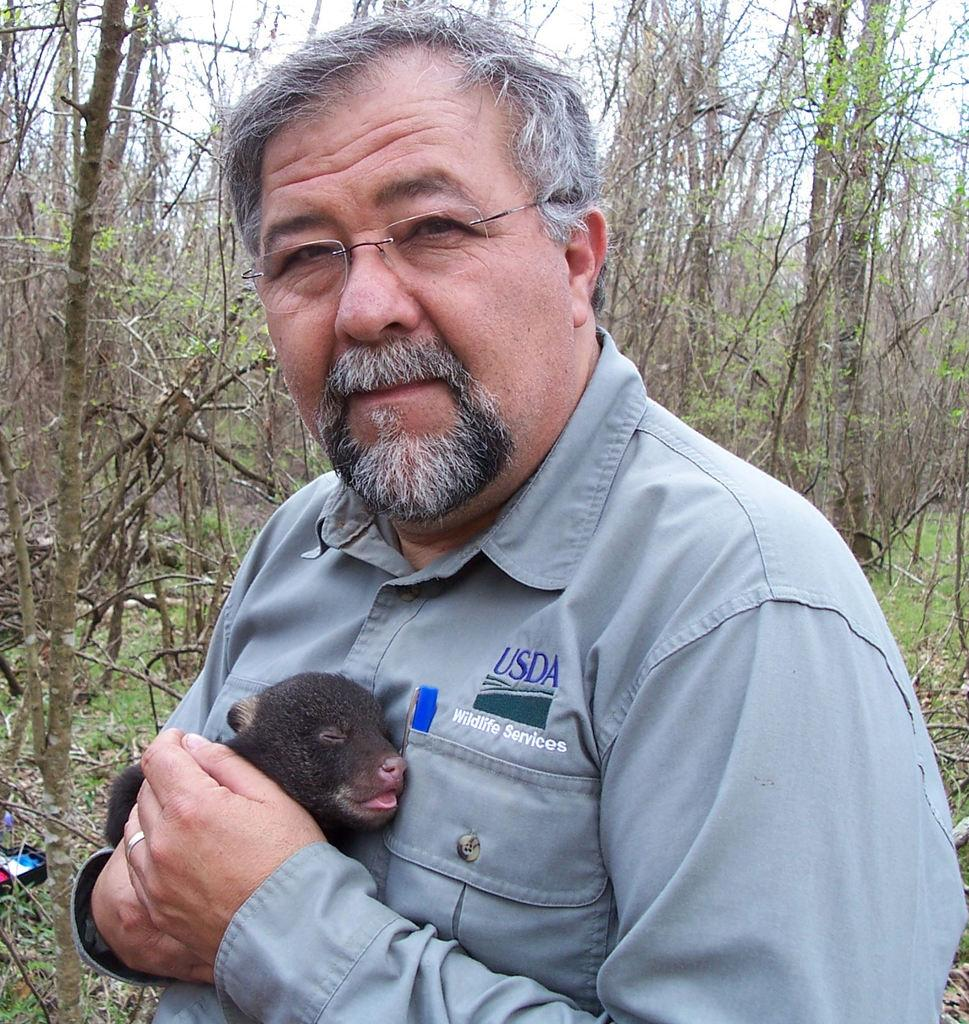What is the main subject of the image? The main subject of the image is a man. What is the man doing in the image? The man is holding an animal in his hands. What can be seen in the background of the image? There are trees in the background of the image. What type of education does the animal in the image have? The image does not provide information about the animal's education, as it only shows the man holding the animal in his hands. 